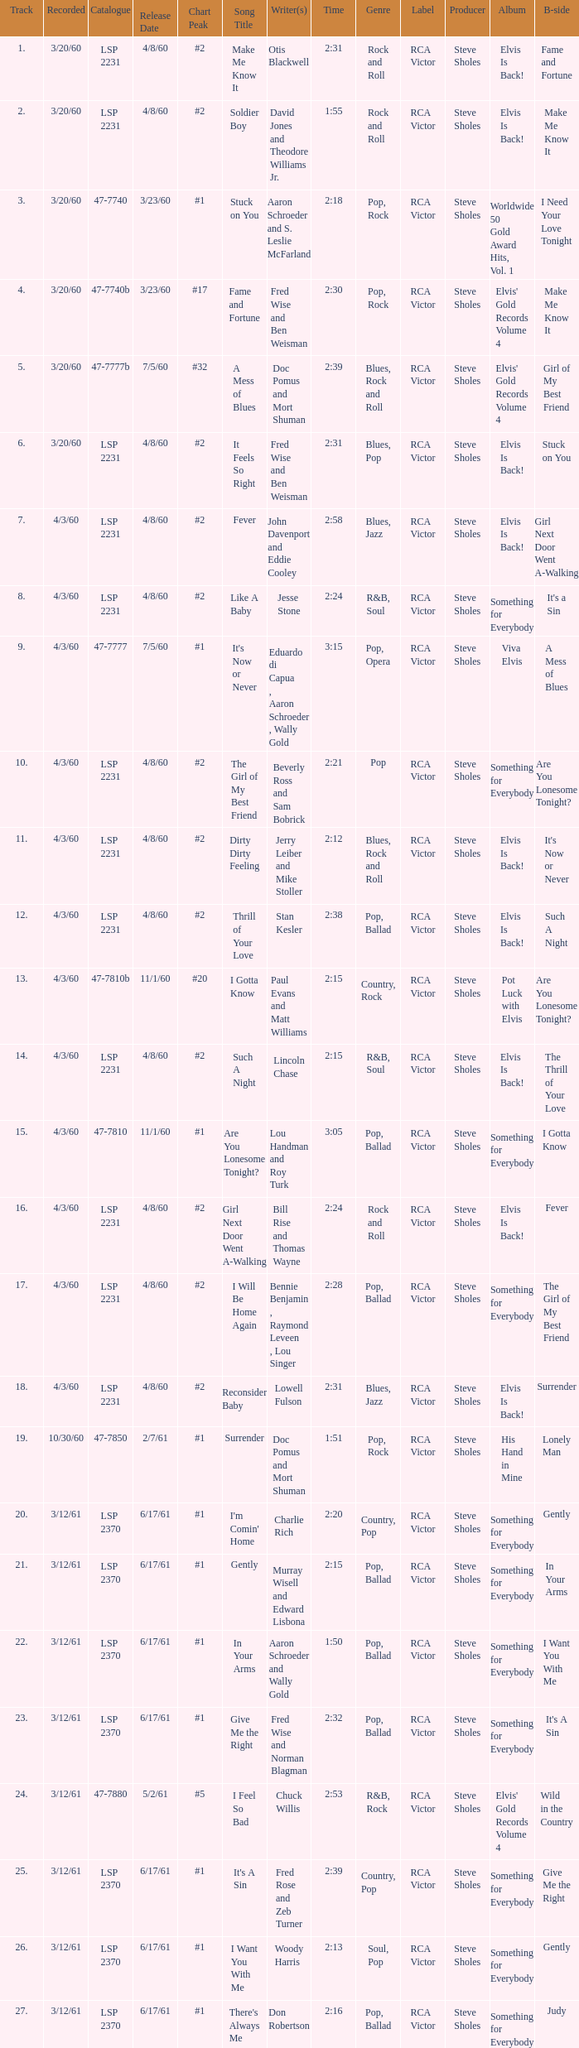What catalogue is the song It's Now or Never? 47-7777. 